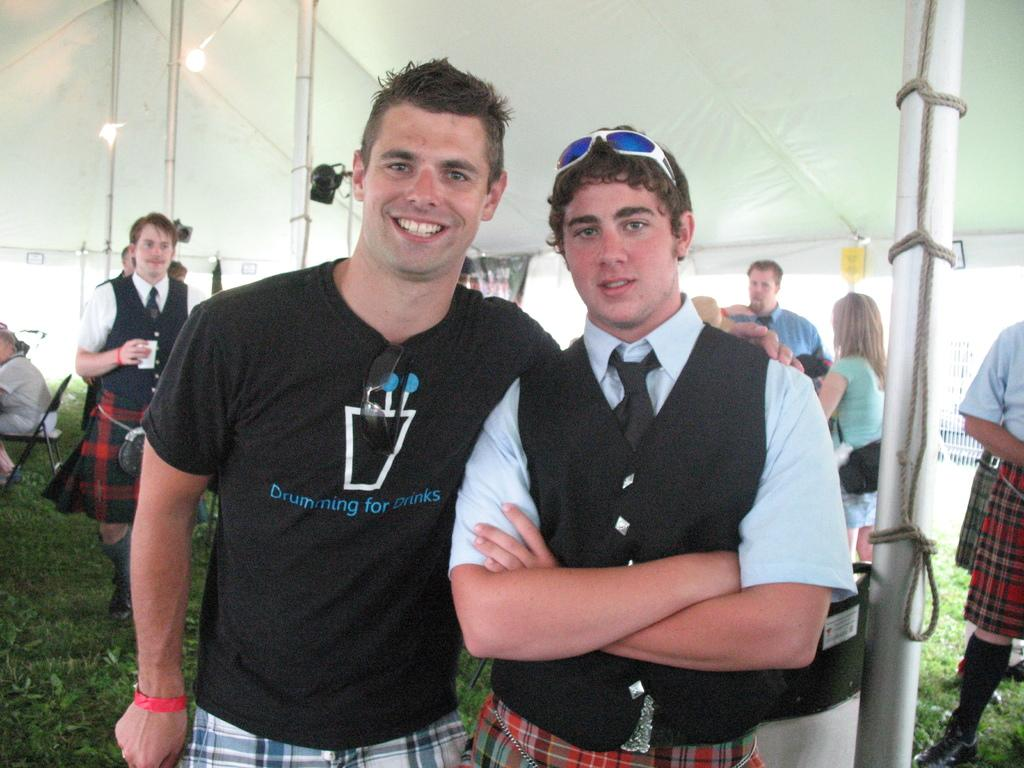What is the main gathering or event in the image? There are people standing under a tent in the image, which suggests a gathering or event. Can you describe the position of one of the individuals in the image? There is a person sitting on a chair at the center left most of the image. How many pizzas are being served at the event in the image? There is no information about pizzas being served in the image. What is the person sitting on the chair at the center left most of the image laughing at? The image does not provide any information about the person laughing or what they might be laughing at. 